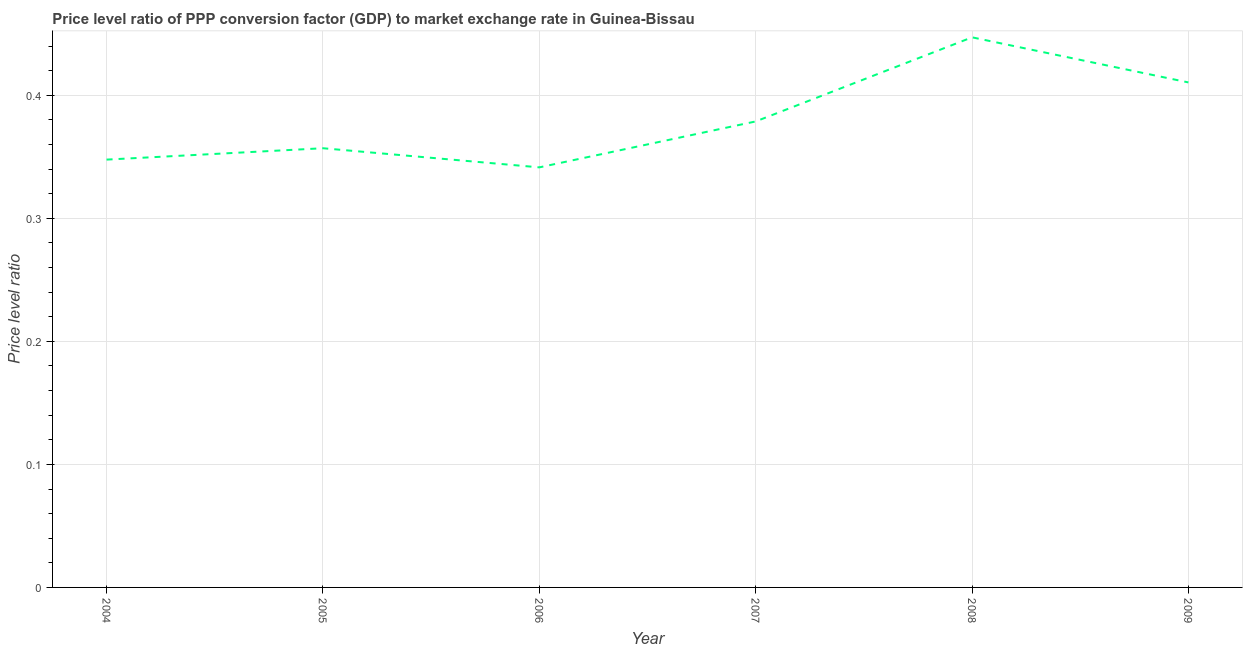What is the price level ratio in 2004?
Ensure brevity in your answer.  0.35. Across all years, what is the maximum price level ratio?
Give a very brief answer. 0.45. Across all years, what is the minimum price level ratio?
Provide a short and direct response. 0.34. In which year was the price level ratio minimum?
Give a very brief answer. 2006. What is the sum of the price level ratio?
Keep it short and to the point. 2.28. What is the difference between the price level ratio in 2004 and 2007?
Make the answer very short. -0.03. What is the average price level ratio per year?
Make the answer very short. 0.38. What is the median price level ratio?
Keep it short and to the point. 0.37. In how many years, is the price level ratio greater than 0.4 ?
Offer a very short reply. 2. What is the ratio of the price level ratio in 2004 to that in 2009?
Offer a terse response. 0.85. Is the price level ratio in 2005 less than that in 2008?
Your response must be concise. Yes. What is the difference between the highest and the second highest price level ratio?
Keep it short and to the point. 0.04. What is the difference between the highest and the lowest price level ratio?
Your answer should be very brief. 0.11. In how many years, is the price level ratio greater than the average price level ratio taken over all years?
Your response must be concise. 2. How many years are there in the graph?
Your response must be concise. 6. Does the graph contain any zero values?
Your response must be concise. No. Does the graph contain grids?
Your answer should be very brief. Yes. What is the title of the graph?
Ensure brevity in your answer.  Price level ratio of PPP conversion factor (GDP) to market exchange rate in Guinea-Bissau. What is the label or title of the Y-axis?
Your response must be concise. Price level ratio. What is the Price level ratio in 2004?
Offer a very short reply. 0.35. What is the Price level ratio of 2005?
Offer a terse response. 0.36. What is the Price level ratio in 2006?
Make the answer very short. 0.34. What is the Price level ratio of 2007?
Provide a short and direct response. 0.38. What is the Price level ratio in 2008?
Your answer should be very brief. 0.45. What is the Price level ratio of 2009?
Offer a very short reply. 0.41. What is the difference between the Price level ratio in 2004 and 2005?
Give a very brief answer. -0.01. What is the difference between the Price level ratio in 2004 and 2006?
Keep it short and to the point. 0.01. What is the difference between the Price level ratio in 2004 and 2007?
Give a very brief answer. -0.03. What is the difference between the Price level ratio in 2004 and 2008?
Provide a short and direct response. -0.1. What is the difference between the Price level ratio in 2004 and 2009?
Provide a short and direct response. -0.06. What is the difference between the Price level ratio in 2005 and 2006?
Make the answer very short. 0.02. What is the difference between the Price level ratio in 2005 and 2007?
Make the answer very short. -0.02. What is the difference between the Price level ratio in 2005 and 2008?
Provide a short and direct response. -0.09. What is the difference between the Price level ratio in 2005 and 2009?
Provide a succinct answer. -0.05. What is the difference between the Price level ratio in 2006 and 2007?
Provide a short and direct response. -0.04. What is the difference between the Price level ratio in 2006 and 2008?
Your answer should be compact. -0.11. What is the difference between the Price level ratio in 2006 and 2009?
Your answer should be compact. -0.07. What is the difference between the Price level ratio in 2007 and 2008?
Keep it short and to the point. -0.07. What is the difference between the Price level ratio in 2007 and 2009?
Offer a terse response. -0.03. What is the difference between the Price level ratio in 2008 and 2009?
Offer a very short reply. 0.04. What is the ratio of the Price level ratio in 2004 to that in 2005?
Provide a short and direct response. 0.97. What is the ratio of the Price level ratio in 2004 to that in 2006?
Provide a short and direct response. 1.02. What is the ratio of the Price level ratio in 2004 to that in 2007?
Give a very brief answer. 0.92. What is the ratio of the Price level ratio in 2004 to that in 2008?
Your answer should be very brief. 0.78. What is the ratio of the Price level ratio in 2004 to that in 2009?
Your answer should be compact. 0.85. What is the ratio of the Price level ratio in 2005 to that in 2006?
Give a very brief answer. 1.05. What is the ratio of the Price level ratio in 2005 to that in 2007?
Provide a succinct answer. 0.94. What is the ratio of the Price level ratio in 2005 to that in 2008?
Your answer should be very brief. 0.8. What is the ratio of the Price level ratio in 2005 to that in 2009?
Your answer should be compact. 0.87. What is the ratio of the Price level ratio in 2006 to that in 2007?
Give a very brief answer. 0.9. What is the ratio of the Price level ratio in 2006 to that in 2008?
Your response must be concise. 0.76. What is the ratio of the Price level ratio in 2006 to that in 2009?
Provide a succinct answer. 0.83. What is the ratio of the Price level ratio in 2007 to that in 2008?
Your response must be concise. 0.85. What is the ratio of the Price level ratio in 2007 to that in 2009?
Give a very brief answer. 0.92. What is the ratio of the Price level ratio in 2008 to that in 2009?
Offer a very short reply. 1.09. 